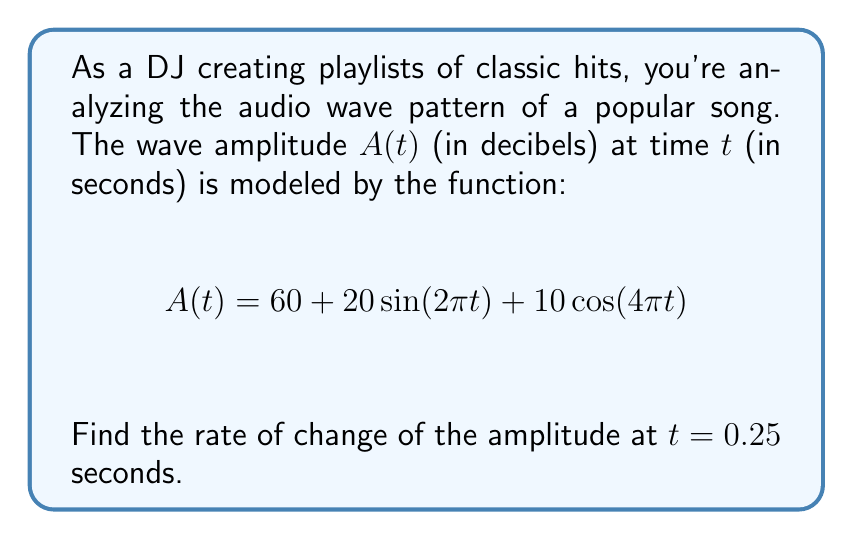What is the answer to this math problem? To find the rate of change of the amplitude at $t = 0.25$ seconds, we need to calculate the derivative of $A(t)$ and then evaluate it at $t = 0.25$.

Step 1: Calculate the derivative of $A(t)$.
$$\frac{d}{dt}A(t) = \frac{d}{dt}[60 + 20\sin(2\pi t) + 10\cos(4\pi t)]$$

Using the chain rule:
$$A'(t) = 20(2\pi)\cos(2\pi t) - 10(4\pi)\sin(4\pi t)$$
$$A'(t) = 40\pi\cos(2\pi t) - 40\pi\sin(4\pi t)$$

Step 2: Evaluate $A'(t)$ at $t = 0.25$.
$$A'(0.25) = 40\pi\cos(2\pi(0.25)) - 40\pi\sin(4\pi(0.25))$$
$$= 40\pi\cos(\frac{\pi}{2}) - 40\pi\sin(\pi)$$
$$= 40\pi(0) - 40\pi(0)$$
$$= 0$$

Therefore, the rate of change of the amplitude at $t = 0.25$ seconds is 0 decibels per second.
Answer: 0 dB/s 